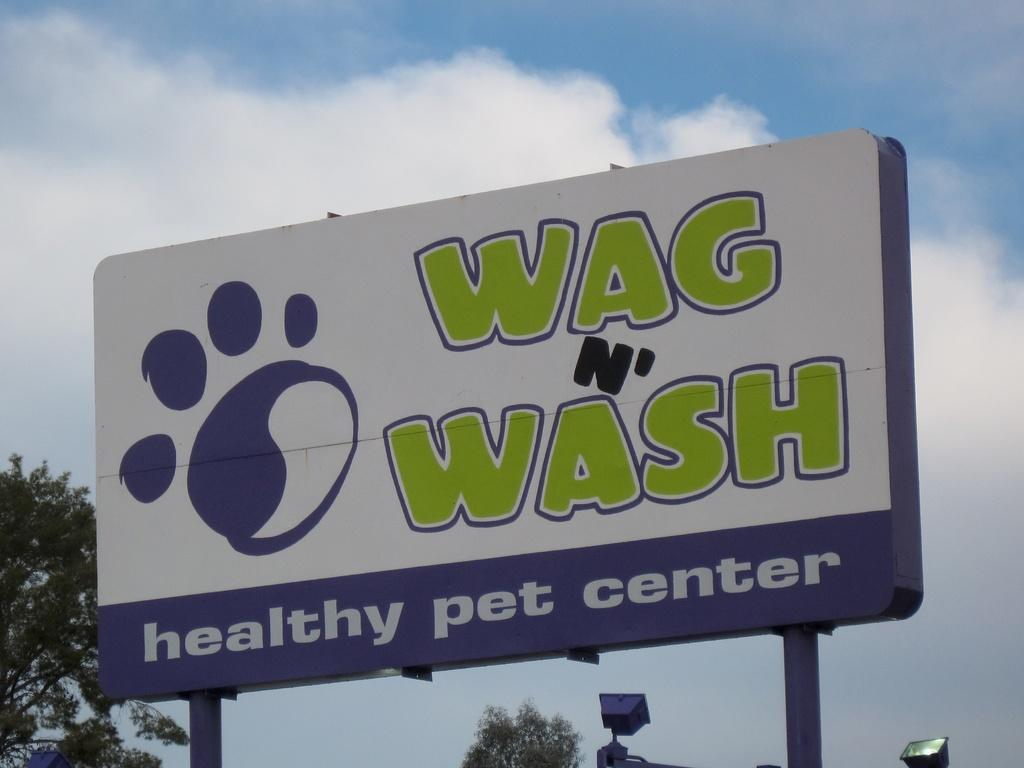Provide a one-sentence caption for the provided image. A billboard for a healthy pet center features green and white text. 